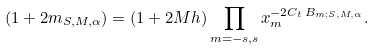Convert formula to latex. <formula><loc_0><loc_0><loc_500><loc_500>( 1 + 2 m _ { S , M , \alpha } ) = ( 1 + 2 M h ) \prod _ { m = - s , s } x _ { m } ^ { - 2 C _ { t } \, B _ { m ; S , M , \alpha } } .</formula> 